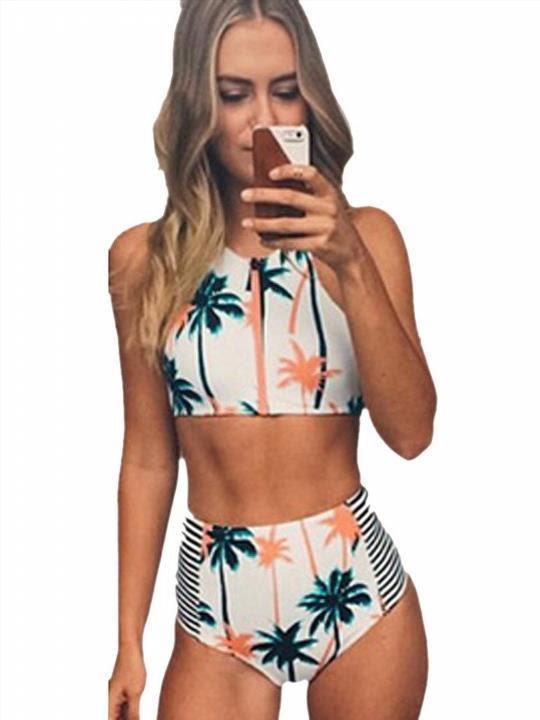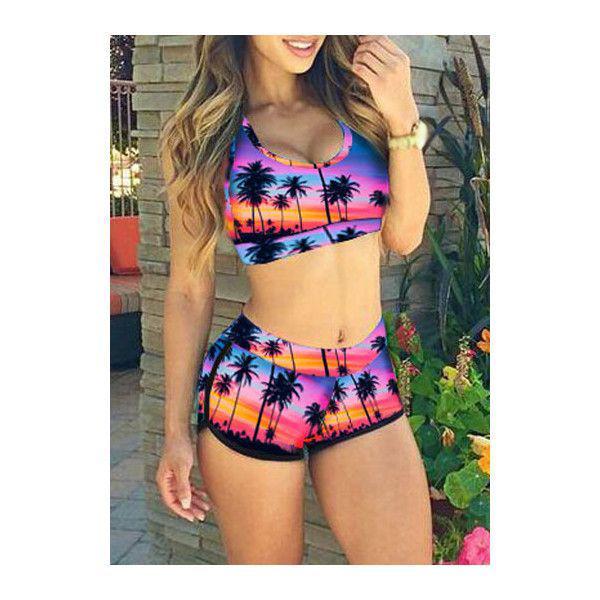The first image is the image on the left, the second image is the image on the right. Given the left and right images, does the statement "At least one of the images shows a very low-rise bikini bottom that hits well below the belly button." hold true? Answer yes or no. No. 